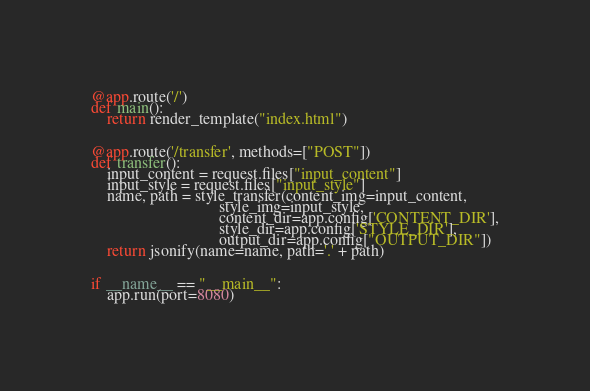Convert code to text. <code><loc_0><loc_0><loc_500><loc_500><_Python_>

@app.route('/')
def main():
    return render_template("index.html")


@app.route('/transfer', methods=["POST"])
def transfer():
    input_content = request.files["input_content"]
    input_style = request.files["input_style"]
    name, path = style_transfer(content_img=input_content,
                                style_img=input_style,
                                content_dir=app.config['CONTENT_DIR'],
                                style_dir=app.config['STYLE_DIR'],
                                output_dir=app.config["OUTPUT_DIR"])
    return jsonify(name=name, path='.' + path)


if __name__ == "__main__":
    app.run(port=8080)
</code> 